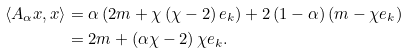Convert formula to latex. <formula><loc_0><loc_0><loc_500><loc_500>\left \langle A _ { \alpha } x , x \right \rangle & = \alpha \left ( 2 m + \chi \left ( \chi - 2 \right ) e _ { k } \right ) + 2 \left ( 1 - \alpha \right ) \left ( m - \chi e _ { k } \right ) \\ & = 2 m + \left ( \alpha \chi - 2 \right ) \chi e _ { k } .</formula> 